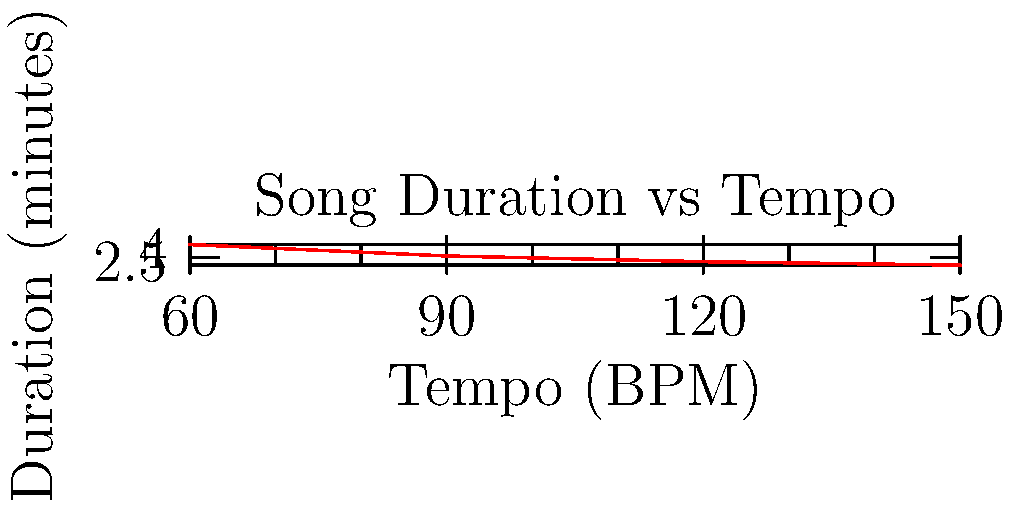During your music therapy session, you're working with a song that has 96 measures. The therapist explains that the song's tempo is 120 beats per minute (BPM), and each measure contains 4 beats. Using this information and the graph provided, calculate the duration of the song in minutes. Let's break this down step-by-step:

1. First, we need to understand what the given information means:
   - The song has 96 measures
   - The tempo is 120 BPM (beats per minute)
   - Each measure contains 4 beats

2. To find the total number of beats in the song:
   $\text{Total beats} = \text{Number of measures} \times \text{Beats per measure}$
   $\text{Total beats} = 96 \times 4 = 384 \text{ beats}$

3. Now, we know the song has 384 beats and is played at 120 BPM.
   To find the duration, we divide the total beats by the beats per minute:

   $\text{Duration (in minutes)} = \frac{\text{Total beats}}{\text{Beats per minute}}$
   $\text{Duration} = \frac{384}{120} = 3.2 \text{ minutes}$

4. We can verify this using the graph:
   - Find 120 on the x-axis (Tempo)
   - Move up to the line on the graph
   - Read the corresponding value on the y-axis (Duration)
   
   The graph shows that at 120 BPM, a single measure (4 beats) would last about 2 seconds.
   Our song has 96 measures, so it would last 96 times longer: $96 \times 2 = 192$ seconds, or 3.2 minutes.

Therefore, the duration of the song is 3.2 minutes.
Answer: 3.2 minutes 